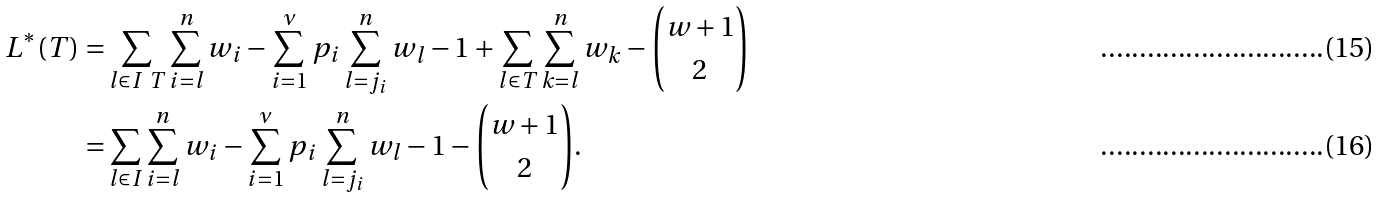Convert formula to latex. <formula><loc_0><loc_0><loc_500><loc_500>L ^ { * } ( T ) = & \sum _ { l \in I \ T } \sum _ { i = l } ^ { n } w _ { i } - \sum _ { i = 1 } ^ { \nu } p _ { i } \sum _ { l = j _ { i } } ^ { n } w _ { l } - 1 + \sum _ { l \in T } \sum _ { k = l } ^ { n } w _ { k } - { w + 1 \choose 2 } \\ = & \sum _ { l \in I } \sum _ { i = l } ^ { n } w _ { i } - \sum _ { i = 1 } ^ { \nu } p _ { i } \sum _ { l = j _ { i } } ^ { n } w _ { l } - 1 - { w + 1 \choose 2 } .</formula> 